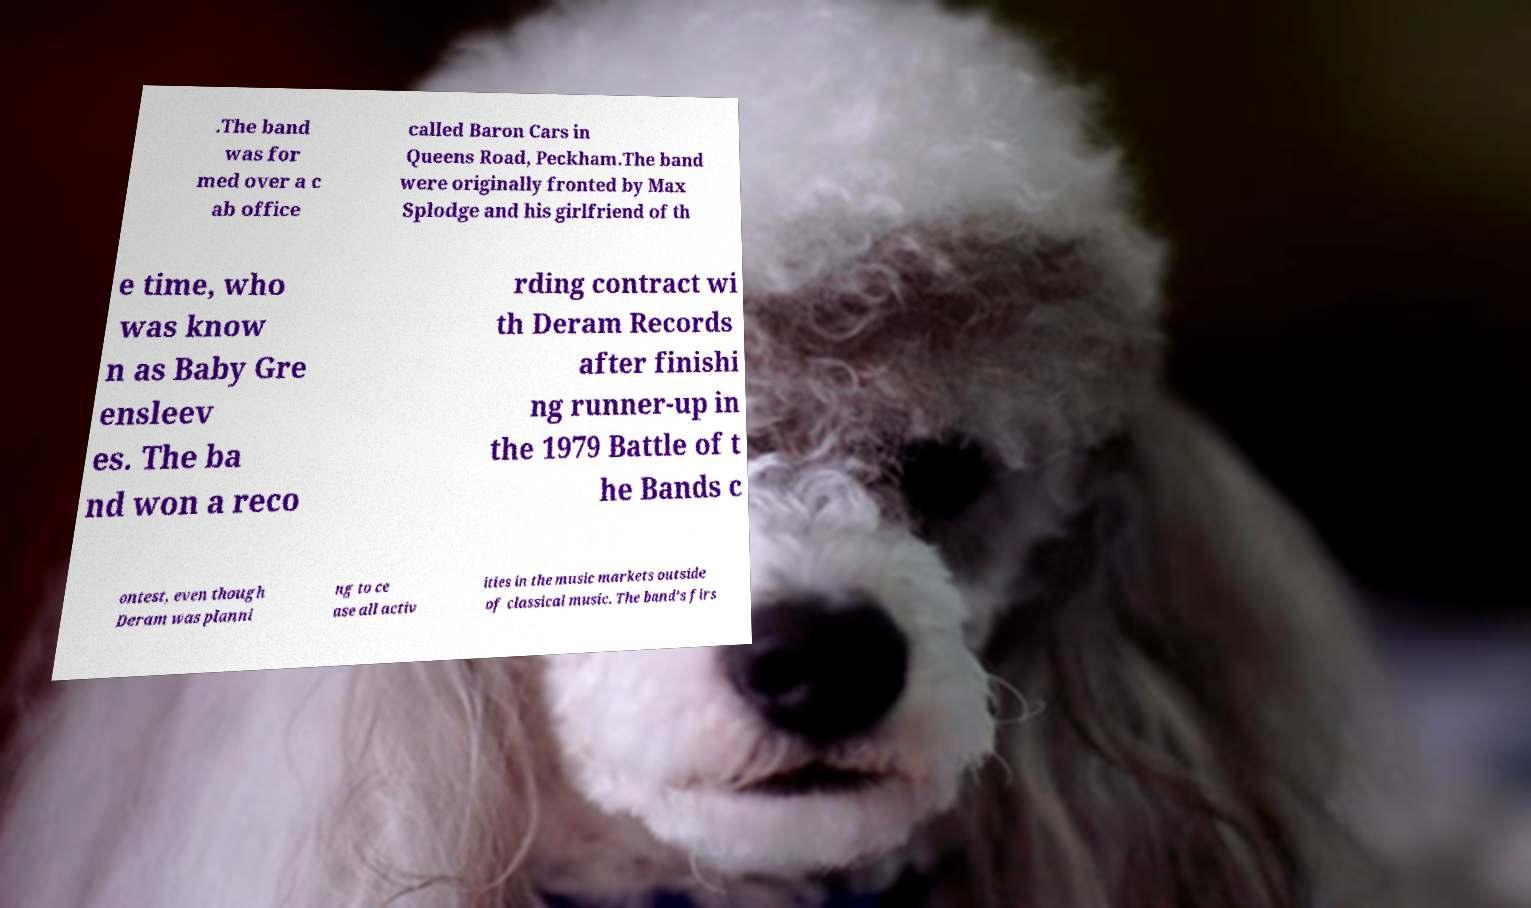There's text embedded in this image that I need extracted. Can you transcribe it verbatim? .The band was for med over a c ab office called Baron Cars in Queens Road, Peckham.The band were originally fronted by Max Splodge and his girlfriend of th e time, who was know n as Baby Gre ensleev es. The ba nd won a reco rding contract wi th Deram Records after finishi ng runner-up in the 1979 Battle of t he Bands c ontest, even though Deram was planni ng to ce ase all activ ities in the music markets outside of classical music. The band's firs 